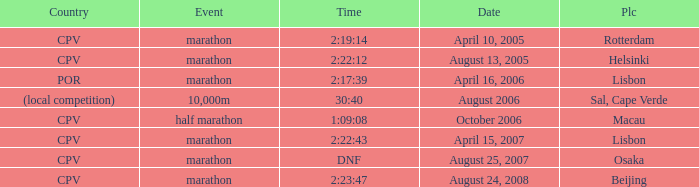What is the Country of the Half Marathon Event? CPV. 